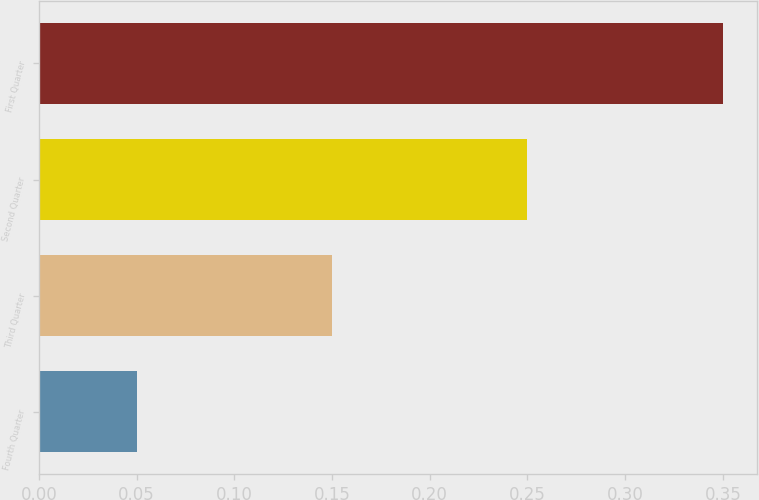Convert chart. <chart><loc_0><loc_0><loc_500><loc_500><bar_chart><fcel>Fourth Quarter<fcel>Third Quarter<fcel>Second Quarter<fcel>First Quarter<nl><fcel>0.05<fcel>0.15<fcel>0.25<fcel>0.35<nl></chart> 